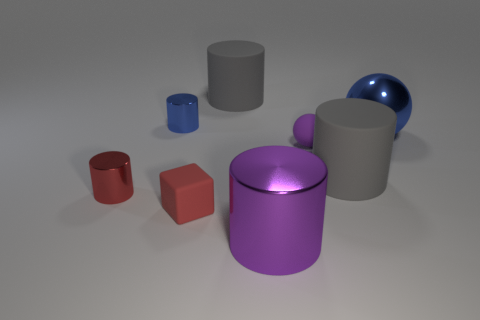Subtract all matte cylinders. How many cylinders are left? 3 Add 2 big things. How many objects exist? 10 Subtract all blue spheres. How many spheres are left? 1 Subtract 1 blue cylinders. How many objects are left? 7 Subtract all cubes. How many objects are left? 7 Subtract 3 cylinders. How many cylinders are left? 2 Subtract all red cylinders. Subtract all purple cubes. How many cylinders are left? 4 Subtract all gray blocks. How many purple balls are left? 1 Subtract all metal cubes. Subtract all small metallic objects. How many objects are left? 6 Add 8 tiny blue cylinders. How many tiny blue cylinders are left? 9 